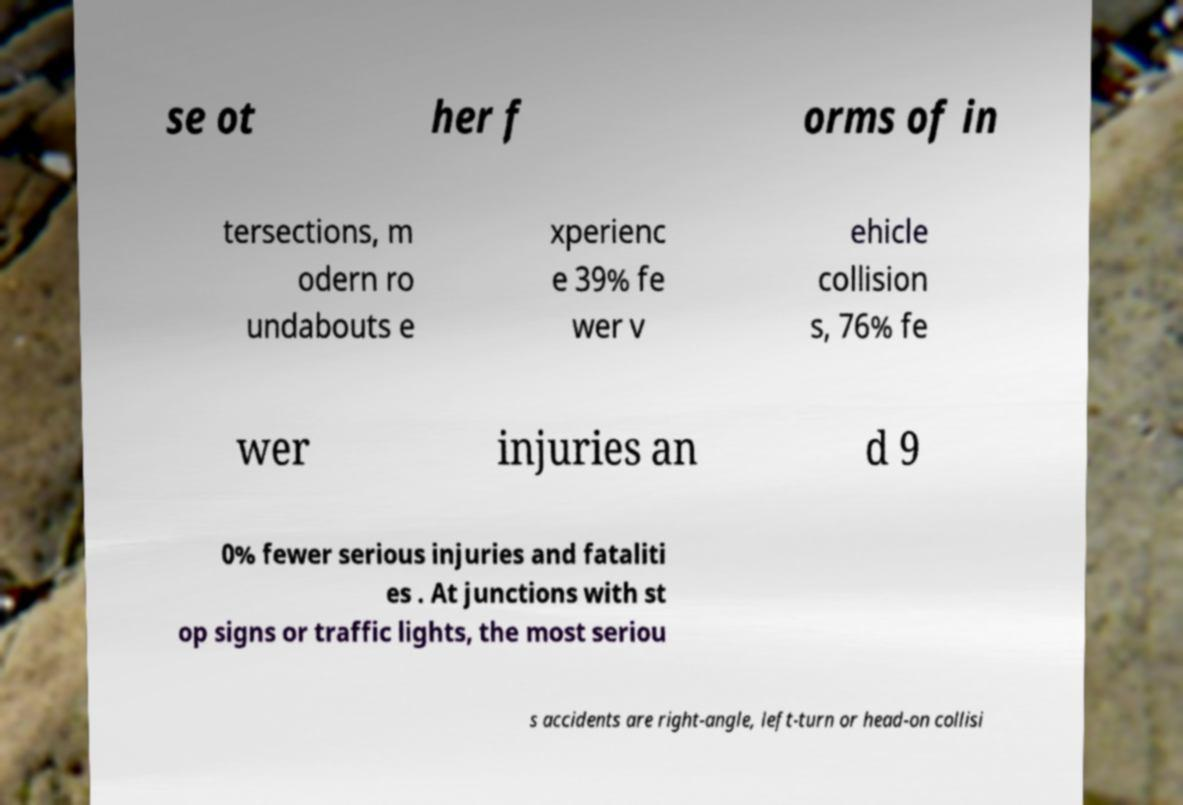Please read and relay the text visible in this image. What does it say? se ot her f orms of in tersections, m odern ro undabouts e xperienc e 39% fe wer v ehicle collision s, 76% fe wer injuries an d 9 0% fewer serious injuries and fataliti es . At junctions with st op signs or traffic lights, the most seriou s accidents are right-angle, left-turn or head-on collisi 